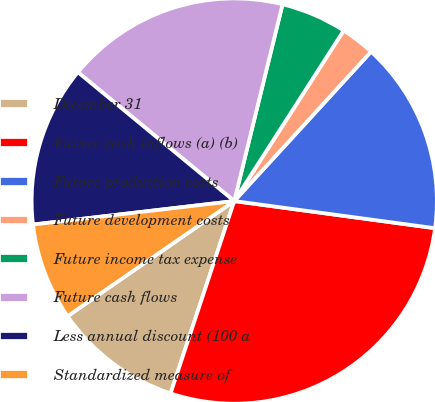Convert chart to OTSL. <chart><loc_0><loc_0><loc_500><loc_500><pie_chart><fcel>December 31<fcel>Future cash inflows (a) (b)<fcel>Future production costs<fcel>Future development costs<fcel>Future income tax expense<fcel>Future cash flows<fcel>Less annual discount (100 a<fcel>Standardized measure of<nl><fcel>10.29%<fcel>27.95%<fcel>15.34%<fcel>2.72%<fcel>5.25%<fcel>17.86%<fcel>12.82%<fcel>7.77%<nl></chart> 